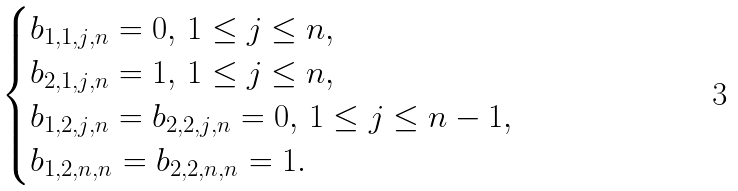Convert formula to latex. <formula><loc_0><loc_0><loc_500><loc_500>\begin{cases} b _ { 1 , 1 , j , n } = 0 , \, 1 \leq j \leq n , \\ b _ { 2 , 1 , j , n } = 1 , \, 1 \leq j \leq n , \\ b _ { 1 , 2 , j , n } = b _ { 2 , 2 , j , n } = 0 , \, 1 \leq j \leq n - 1 , \\ b _ { 1 , 2 , n , n } = b _ { 2 , 2 , n , n } = 1 . \\ \end{cases}</formula> 